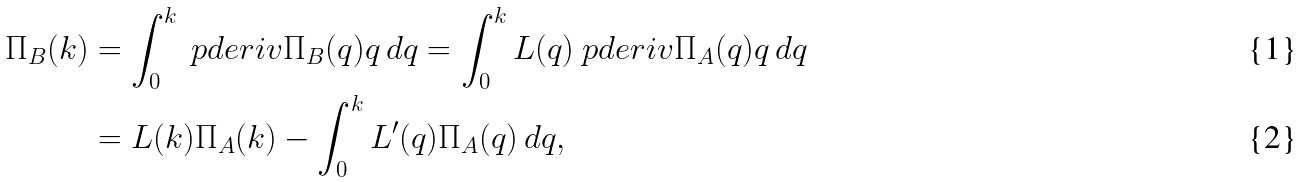Convert formula to latex. <formula><loc_0><loc_0><loc_500><loc_500>\Pi _ { B } ( k ) & = \int _ { 0 } ^ { k } \ p d e r i v { \Pi _ { B } ( q ) } { q } \, d q = \int _ { 0 } ^ { k } L ( q ) \ p d e r i v { \Pi _ { A } ( q ) } { q } \, d q \\ & = L ( k ) \Pi _ { A } ( k ) - \int _ { 0 } ^ { k } L ^ { \prime } ( q ) \Pi _ { A } ( q ) \, d q ,</formula> 